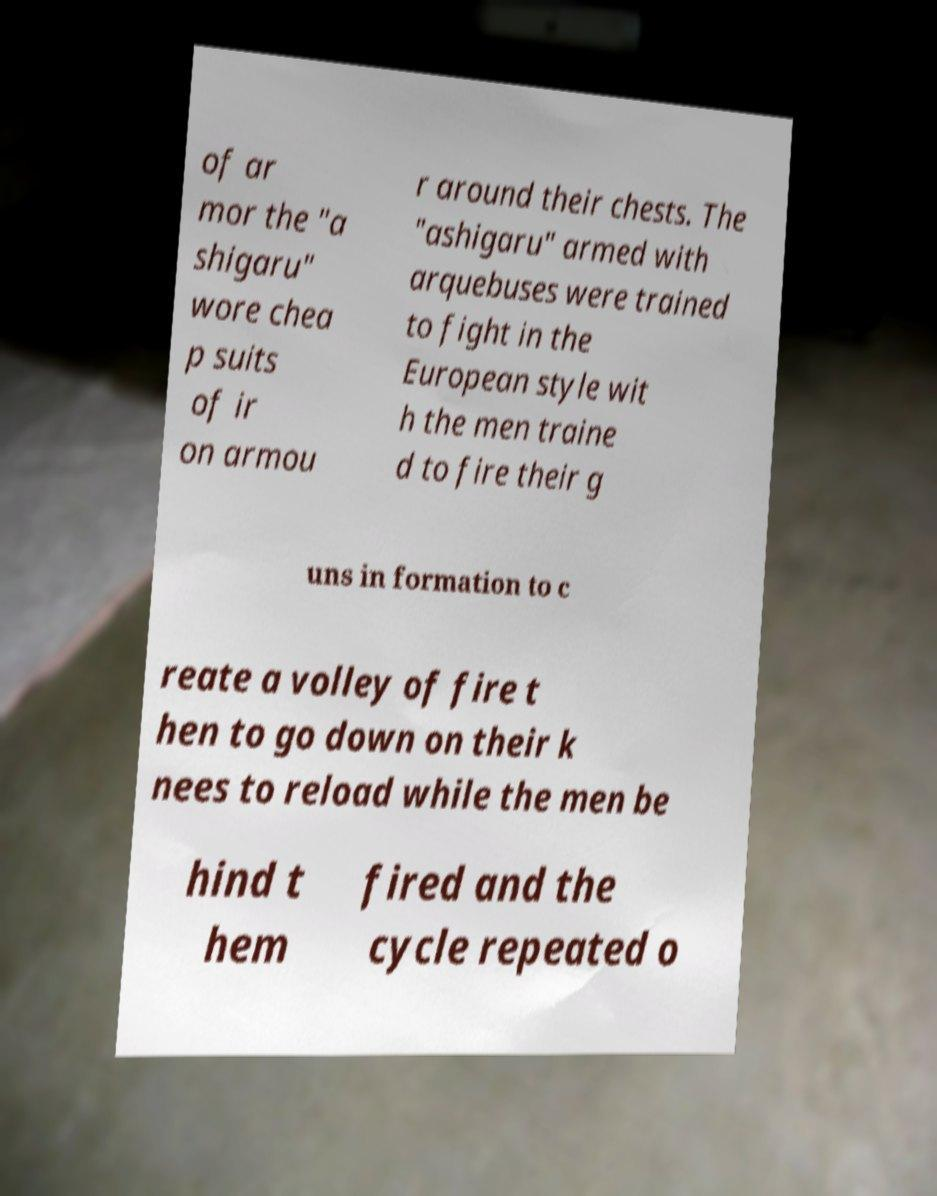There's text embedded in this image that I need extracted. Can you transcribe it verbatim? of ar mor the "a shigaru" wore chea p suits of ir on armou r around their chests. The "ashigaru" armed with arquebuses were trained to fight in the European style wit h the men traine d to fire their g uns in formation to c reate a volley of fire t hen to go down on their k nees to reload while the men be hind t hem fired and the cycle repeated o 